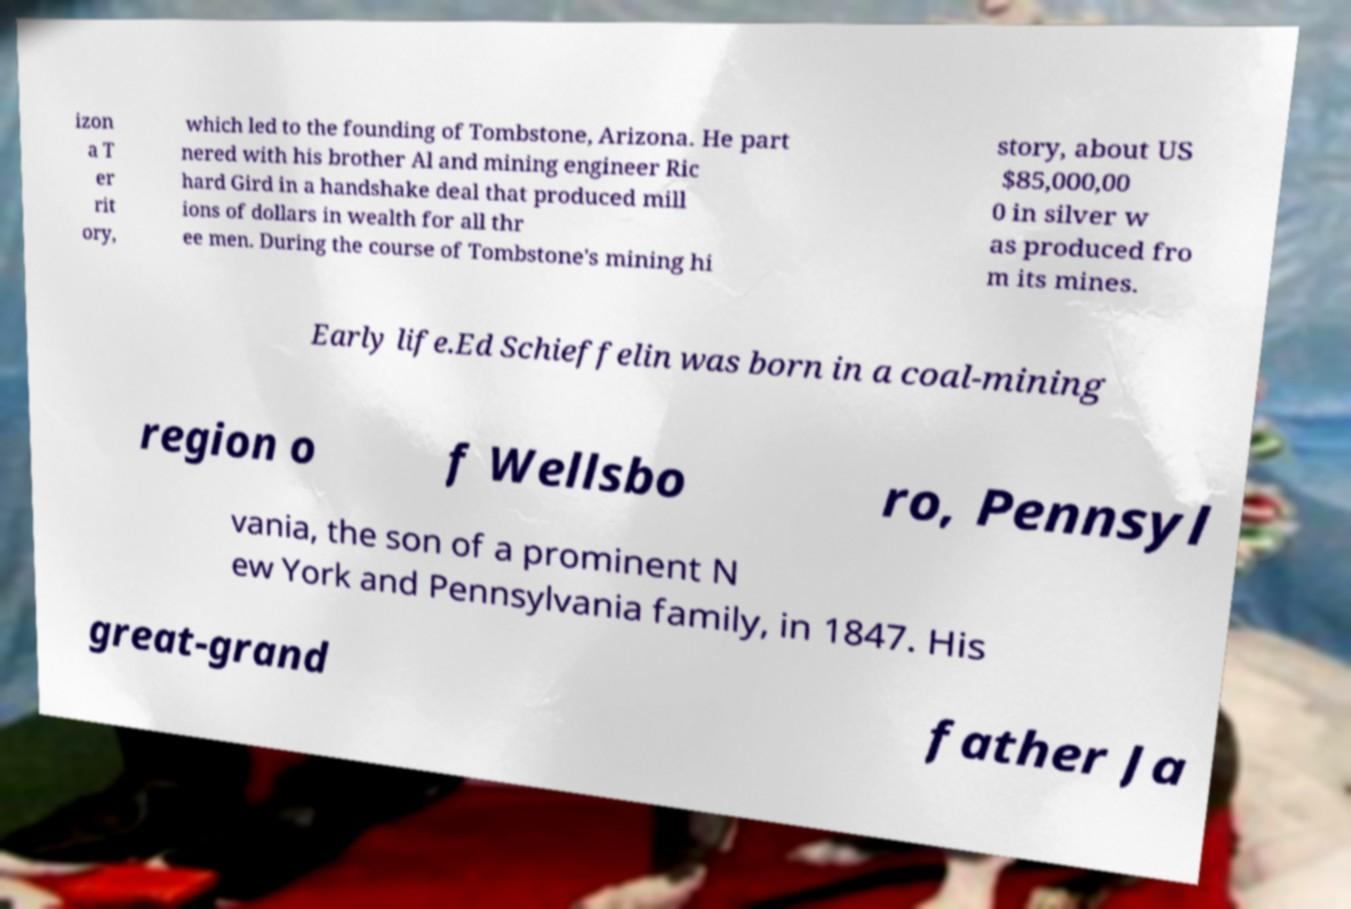Could you extract and type out the text from this image? izon a T er rit ory, which led to the founding of Tombstone, Arizona. He part nered with his brother Al and mining engineer Ric hard Gird in a handshake deal that produced mill ions of dollars in wealth for all thr ee men. During the course of Tombstone's mining hi story, about US $85,000,00 0 in silver w as produced fro m its mines. Early life.Ed Schieffelin was born in a coal-mining region o f Wellsbo ro, Pennsyl vania, the son of a prominent N ew York and Pennsylvania family, in 1847. His great-grand father Ja 